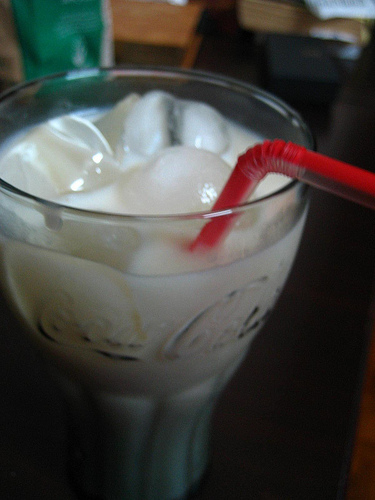<image>
Can you confirm if the straw is in the cup? Yes. The straw is contained within or inside the cup, showing a containment relationship. 